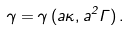<formula> <loc_0><loc_0><loc_500><loc_500>\gamma = \gamma \, ( a \kappa , a ^ { 2 } \Gamma ) \, .</formula> 